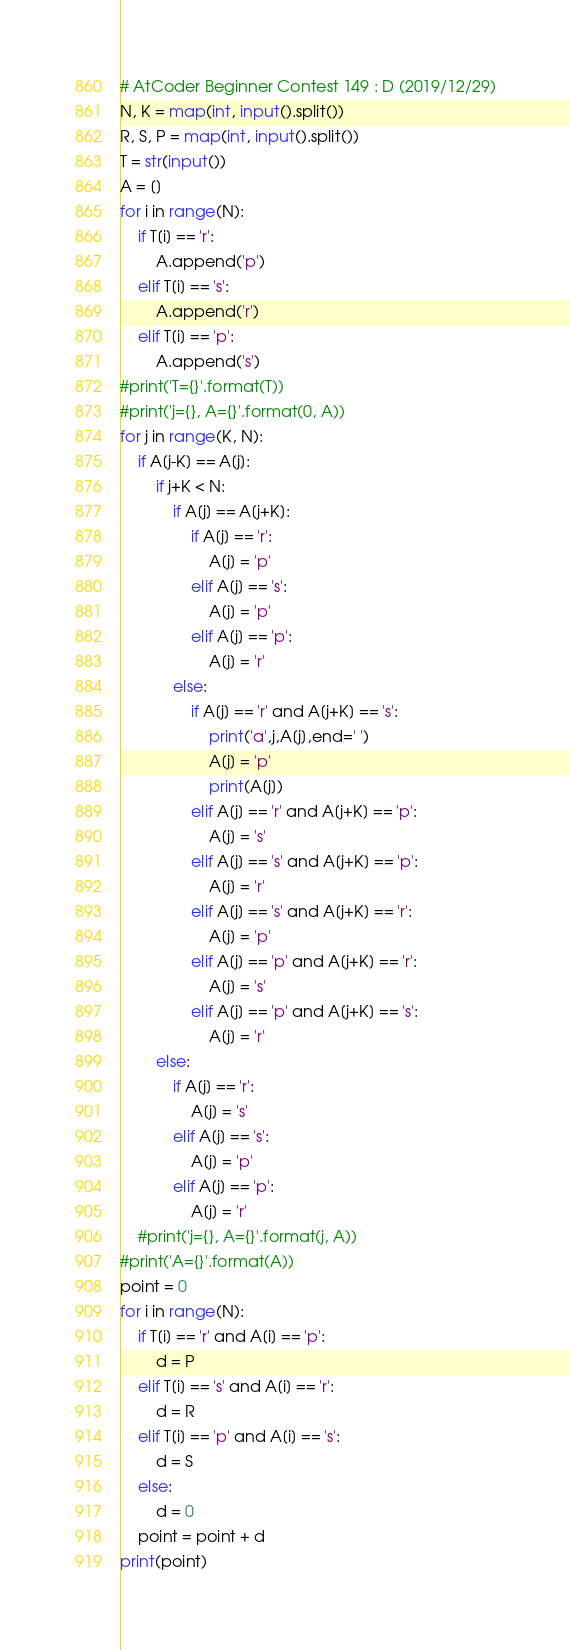Convert code to text. <code><loc_0><loc_0><loc_500><loc_500><_Python_># AtCoder Beginner Contest 149 : D (2019/12/29)
N, K = map(int, input().split())
R, S, P = map(int, input().split())
T = str(input())
A = []
for i in range(N):
    if T[i] == 'r':
        A.append('p')
    elif T[i] == 's':
        A.append('r')
    elif T[i] == 'p':
        A.append('s')
#print('T={}'.format(T))
#print('j={}, A={}'.format(0, A))
for j in range(K, N):
    if A[j-K] == A[j]:
        if j+K < N:
            if A[j] == A[j+K]:
                if A[j] == 'r':
                    A[j] = 'p'
                elif A[j] == 's':
                    A[j] = 'p'
                elif A[j] == 'p':
                    A[j] = 'r'
            else:
                if A[j] == 'r' and A[j+K] == 's':
                    print('a',j,A[j],end=' ')
                    A[j] = 'p'
                    print(A[j])
                elif A[j] == 'r' and A[j+K] == 'p':
                    A[j] = 's'
                elif A[j] == 's' and A[j+K] == 'p':
                    A[j] = 'r'
                elif A[j] == 's' and A[j+K] == 'r':
                    A[j] = 'p'
                elif A[j] == 'p' and A[j+K] == 'r':
                    A[j] = 's'
                elif A[j] == 'p' and A[j+K] == 's':
                    A[j] = 'r'
        else:
            if A[j] == 'r':
                A[j] = 's'
            elif A[j] == 's':
                A[j] = 'p'
            elif A[j] == 'p':
                A[j] = 'r'
    #print('j={}, A={}'.format(j, A))
#print('A={}'.format(A))
point = 0
for i in range(N):
    if T[i] == 'r' and A[i] == 'p':
        d = P
    elif T[i] == 's' and A[i] == 'r':
        d = R
    elif T[i] == 'p' and A[i] == 's':
        d = S
    else:
        d = 0
    point = point + d
print(point)</code> 